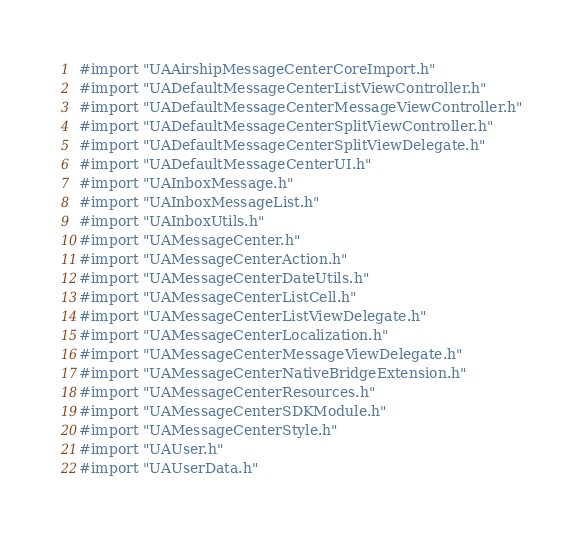Convert code to text. <code><loc_0><loc_0><loc_500><loc_500><_C_>#import "UAAirshipMessageCenterCoreImport.h"
#import "UADefaultMessageCenterListViewController.h"
#import "UADefaultMessageCenterMessageViewController.h"
#import "UADefaultMessageCenterSplitViewController.h"
#import "UADefaultMessageCenterSplitViewDelegate.h"
#import "UADefaultMessageCenterUI.h"
#import "UAInboxMessage.h"
#import "UAInboxMessageList.h"
#import "UAInboxUtils.h"
#import "UAMessageCenter.h"
#import "UAMessageCenterAction.h"
#import "UAMessageCenterDateUtils.h"
#import "UAMessageCenterListCell.h"
#import "UAMessageCenterListViewDelegate.h"
#import "UAMessageCenterLocalization.h"
#import "UAMessageCenterMessageViewDelegate.h"
#import "UAMessageCenterNativeBridgeExtension.h"
#import "UAMessageCenterResources.h"
#import "UAMessageCenterSDKModule.h"
#import "UAMessageCenterStyle.h"
#import "UAUser.h"
#import "UAUserData.h"
</code> 